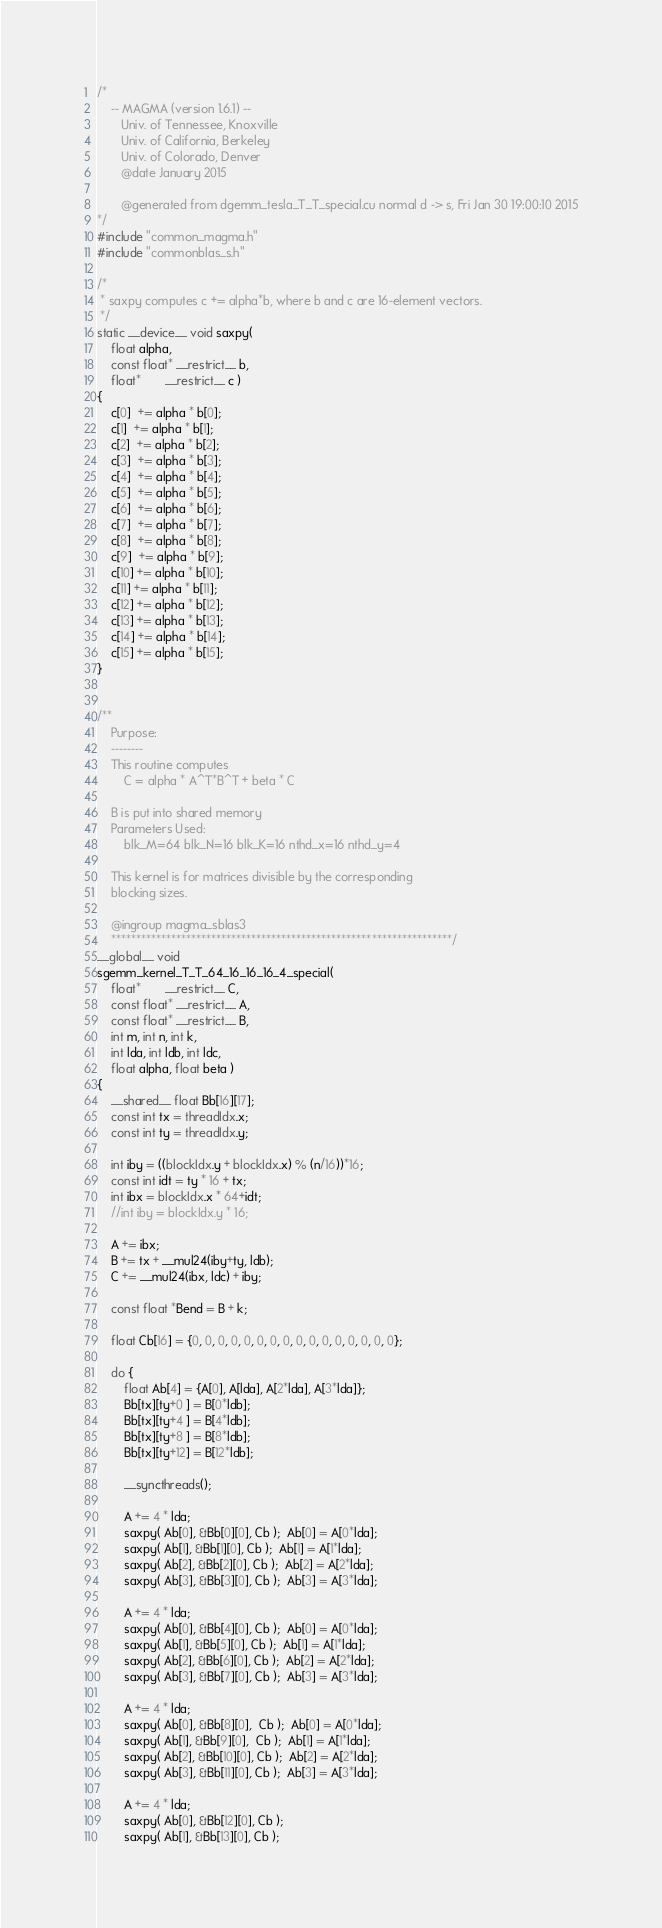<code> <loc_0><loc_0><loc_500><loc_500><_Cuda_>/*
    -- MAGMA (version 1.6.1) --
       Univ. of Tennessee, Knoxville
       Univ. of California, Berkeley
       Univ. of Colorado, Denver
       @date January 2015

       @generated from dgemm_tesla_T_T_special.cu normal d -> s, Fri Jan 30 19:00:10 2015
*/
#include "common_magma.h"
#include "commonblas_s.h"

/*
 * saxpy computes c += alpha*b, where b and c are 16-element vectors.
 */
static __device__ void saxpy(
    float alpha,
    const float* __restrict__ b,
    float*       __restrict__ c )
{
    c[0]  += alpha * b[0];
    c[1]  += alpha * b[1];
    c[2]  += alpha * b[2];
    c[3]  += alpha * b[3];
    c[4]  += alpha * b[4];
    c[5]  += alpha * b[5];
    c[6]  += alpha * b[6];
    c[7]  += alpha * b[7];
    c[8]  += alpha * b[8];
    c[9]  += alpha * b[9];
    c[10] += alpha * b[10];
    c[11] += alpha * b[11];
    c[12] += alpha * b[12];
    c[13] += alpha * b[13];
    c[14] += alpha * b[14];
    c[15] += alpha * b[15];
}


/**
    Purpose:
    --------
    This routine computes
        C = alpha * A^T*B^T + beta * C

    B is put into shared memory
    Parameters Used:
        blk_M=64 blk_N=16 blk_K=16 nthd_x=16 nthd_y=4

    This kernel is for matrices divisible by the corresponding
    blocking sizes.

    @ingroup magma_sblas3
    ********************************************************************/
__global__ void
sgemm_kernel_T_T_64_16_16_16_4_special(
    float*       __restrict__ C,
    const float* __restrict__ A,
    const float* __restrict__ B,
    int m, int n, int k,
    int lda, int ldb, int ldc,
    float alpha, float beta )
{
    __shared__ float Bb[16][17];
    const int tx = threadIdx.x;
    const int ty = threadIdx.y;

    int iby = ((blockIdx.y + blockIdx.x) % (n/16))*16;
    const int idt = ty * 16 + tx;
    int ibx = blockIdx.x * 64+idt;
    //int iby = blockIdx.y * 16;

    A += ibx;
    B += tx + __mul24(iby+ty, ldb);
    C += __mul24(ibx, ldc) + iby;

    const float *Bend = B + k;

    float Cb[16] = {0, 0, 0, 0, 0, 0, 0, 0, 0, 0, 0, 0, 0, 0, 0, 0};

    do {
        float Ab[4] = {A[0], A[lda], A[2*lda], A[3*lda]};
        Bb[tx][ty+0 ] = B[0*ldb];
        Bb[tx][ty+4 ] = B[4*ldb];
        Bb[tx][ty+8 ] = B[8*ldb];
        Bb[tx][ty+12] = B[12*ldb];

        __syncthreads();

        A += 4 * lda;
        saxpy( Ab[0], &Bb[0][0], Cb );  Ab[0] = A[0*lda];
        saxpy( Ab[1], &Bb[1][0], Cb );  Ab[1] = A[1*lda];
        saxpy( Ab[2], &Bb[2][0], Cb );  Ab[2] = A[2*lda];
        saxpy( Ab[3], &Bb[3][0], Cb );  Ab[3] = A[3*lda];

        A += 4 * lda;
        saxpy( Ab[0], &Bb[4][0], Cb );  Ab[0] = A[0*lda];
        saxpy( Ab[1], &Bb[5][0], Cb );  Ab[1] = A[1*lda];
        saxpy( Ab[2], &Bb[6][0], Cb );  Ab[2] = A[2*lda];
        saxpy( Ab[3], &Bb[7][0], Cb );  Ab[3] = A[3*lda];

        A += 4 * lda;
        saxpy( Ab[0], &Bb[8][0],  Cb );  Ab[0] = A[0*lda];
        saxpy( Ab[1], &Bb[9][0],  Cb );  Ab[1] = A[1*lda];
        saxpy( Ab[2], &Bb[10][0], Cb );  Ab[2] = A[2*lda];
        saxpy( Ab[3], &Bb[11][0], Cb );  Ab[3] = A[3*lda];

        A += 4 * lda;
        saxpy( Ab[0], &Bb[12][0], Cb );
        saxpy( Ab[1], &Bb[13][0], Cb );</code> 